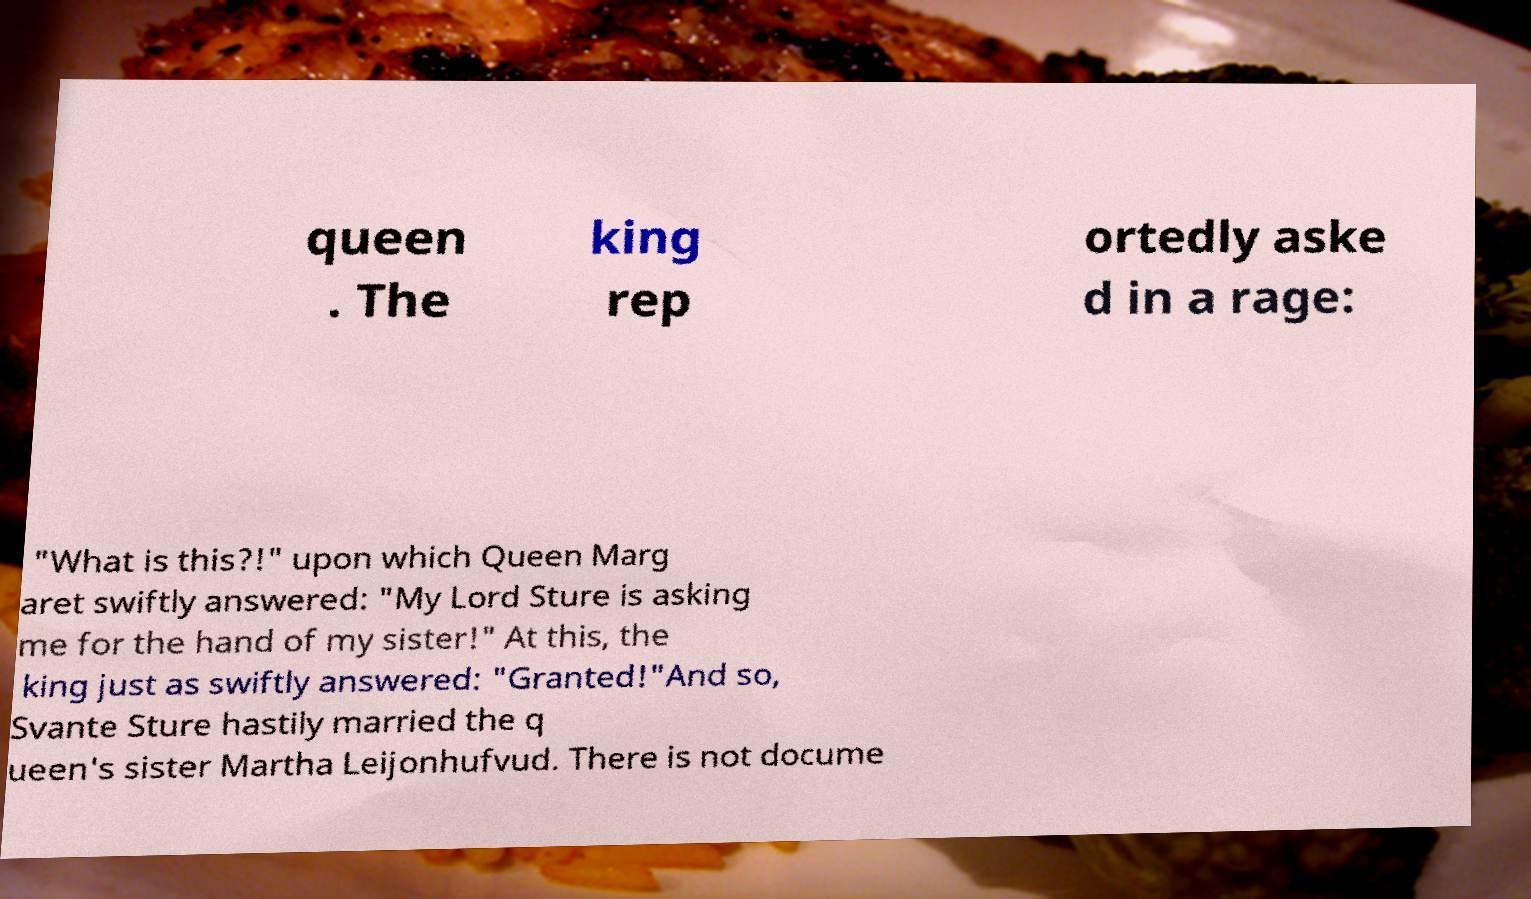Can you accurately transcribe the text from the provided image for me? queen . The king rep ortedly aske d in a rage: "What is this?!" upon which Queen Marg aret swiftly answered: "My Lord Sture is asking me for the hand of my sister!" At this, the king just as swiftly answered: "Granted!"And so, Svante Sture hastily married the q ueen's sister Martha Leijonhufvud. There is not docume 